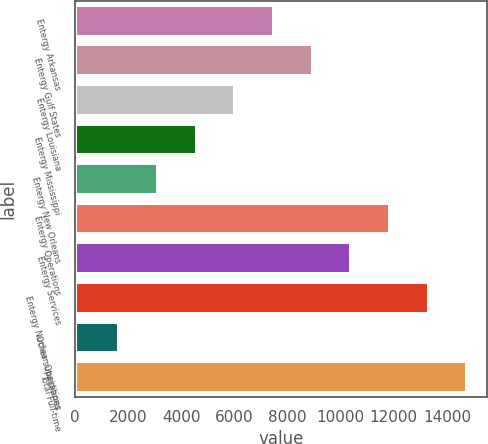Convert chart to OTSL. <chart><loc_0><loc_0><loc_500><loc_500><bar_chart><fcel>Entergy Arkansas<fcel>Entergy Gulf States<fcel>Entergy Louisiana<fcel>Entergy Mississippi<fcel>Entergy New Orleans<fcel>Entergy Operations<fcel>Entergy Services<fcel>Entergy Nuclear Operations<fcel>Other subsidiaries<fcel>Total Full-time<nl><fcel>7491<fcel>8947.4<fcel>6034.6<fcel>4578.2<fcel>3121.8<fcel>11860.2<fcel>10403.8<fcel>13316.6<fcel>1665.4<fcel>14773<nl></chart> 